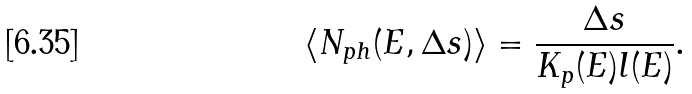<formula> <loc_0><loc_0><loc_500><loc_500>\langle N _ { p h } ( E , \Delta s ) \rangle = \frac { \Delta s } { K _ { p } ( E ) l ( E ) } .</formula> 